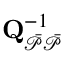Convert formula to latex. <formula><loc_0><loc_0><loc_500><loc_500>Q _ { \mathcal { \ B a r { P } \ B a r { P } } } ^ { - 1 }</formula> 